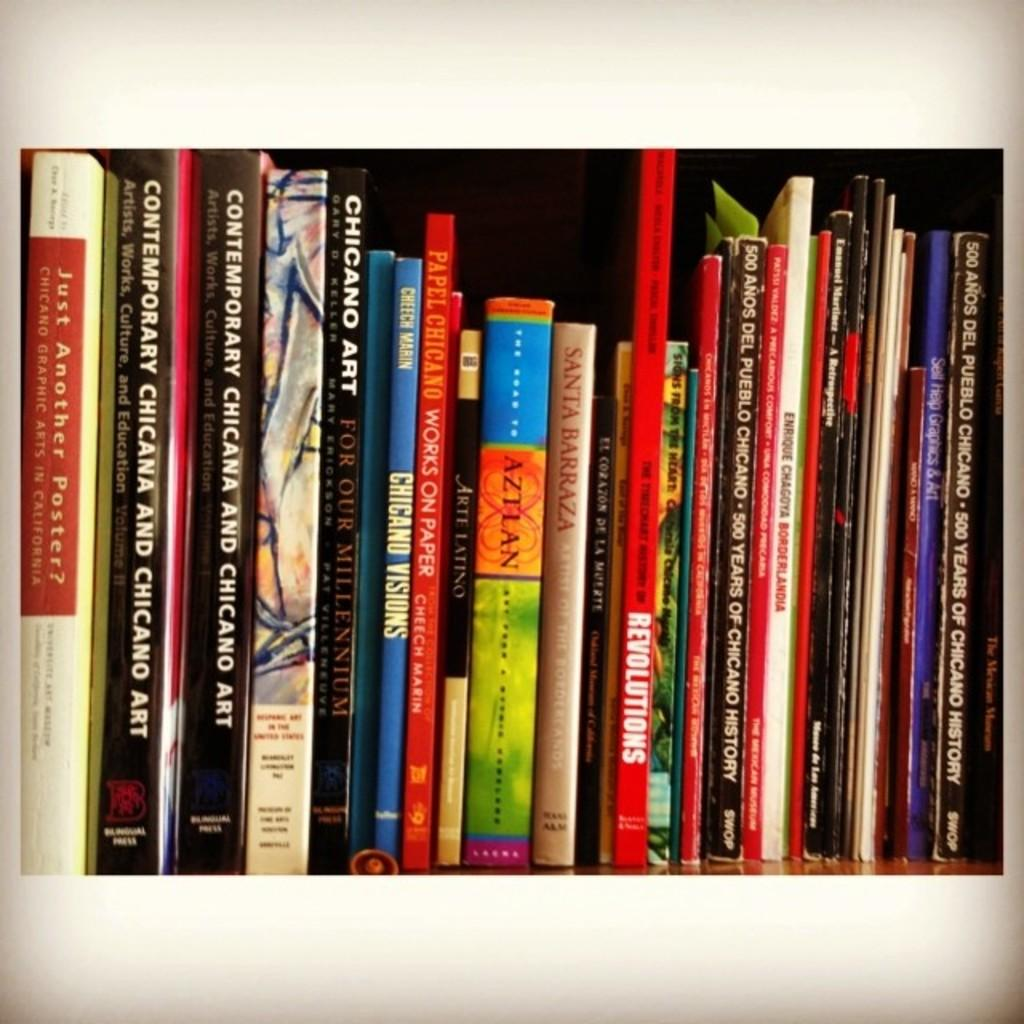<image>
Offer a succinct explanation of the picture presented. A row of colorful books many of them having Chicago and Art in their titles. 